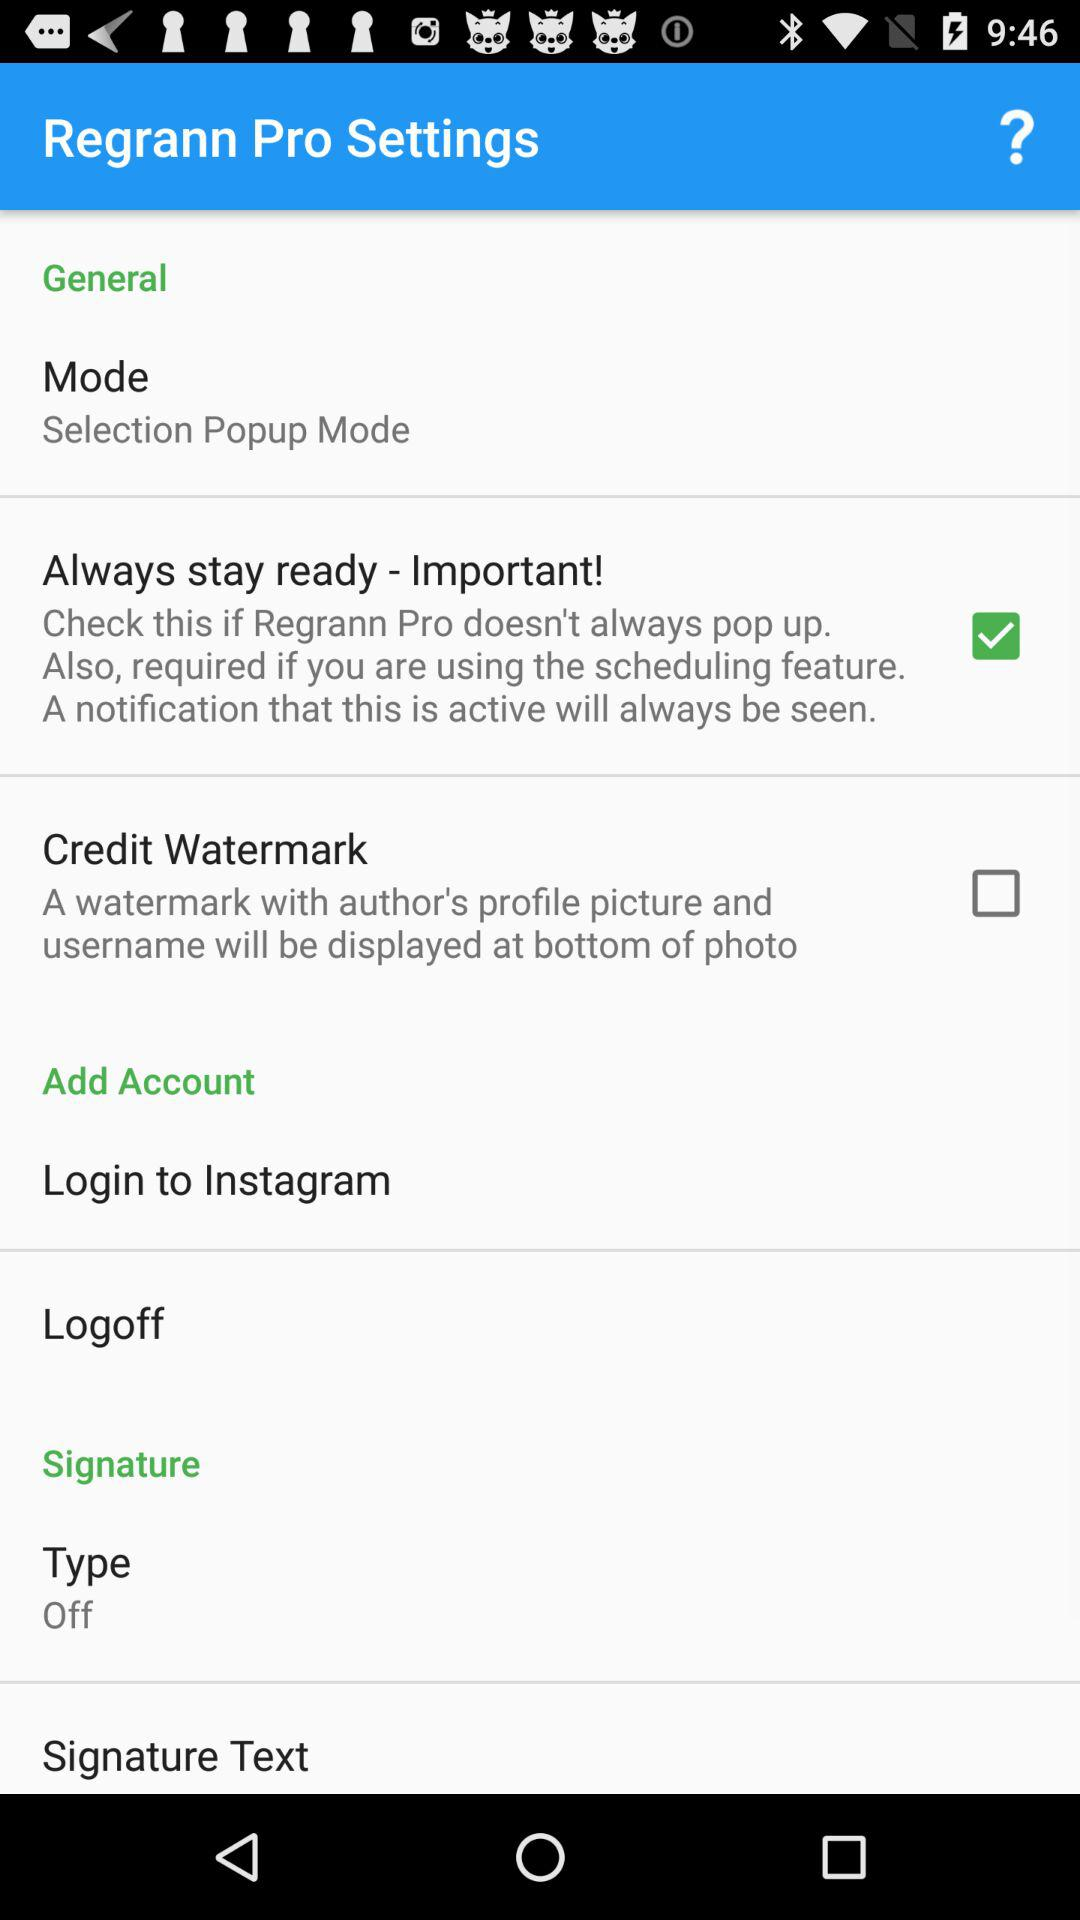Is "General" checked or unchecked?
When the provided information is insufficient, respond with <no answer>. <no answer> 